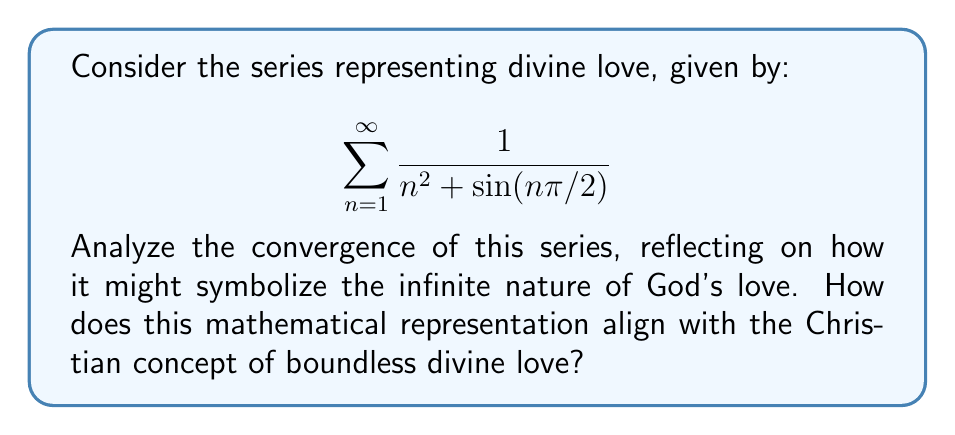Solve this math problem. To analyze the convergence of this series, we'll use the comparison test:

1) First, observe that $\sin(n\pi/2)$ oscillates between -1 and 1 for all n.

2) Therefore, we can establish bounds:
   $$\frac{1}{n^2 + 1} \leq \frac{1}{n^2 + \sin(n\pi/2)} \leq \frac{1}{n^2 - 1}$$

3) For large n, both $\frac{1}{n^2 + 1}$ and $\frac{1}{n^2 - 1}$ behave similarly to $\frac{1}{n^2}$.

4) We know that $\sum_{n=1}^{\infty} \frac{1}{n^2}$ converges (it's the Basel problem, with sum $\frac{\pi^2}{6}$).

5) By the comparison test, since our series is bounded above and below by convergent series, it must also converge.

6) The convergence of this series to a finite value could symbolize how divine love, while infinite in nature, is also complete and perfect in itself.

7) The gradual decrease of terms as n increases might represent how each individual's experience of divine love, while always present, can feel more subtle as one grows in faith.

8) The oscillation introduced by the sine term could represent the ebbs and flows in one's perception of divine love throughout life's journey.
Answer: The series converges. 